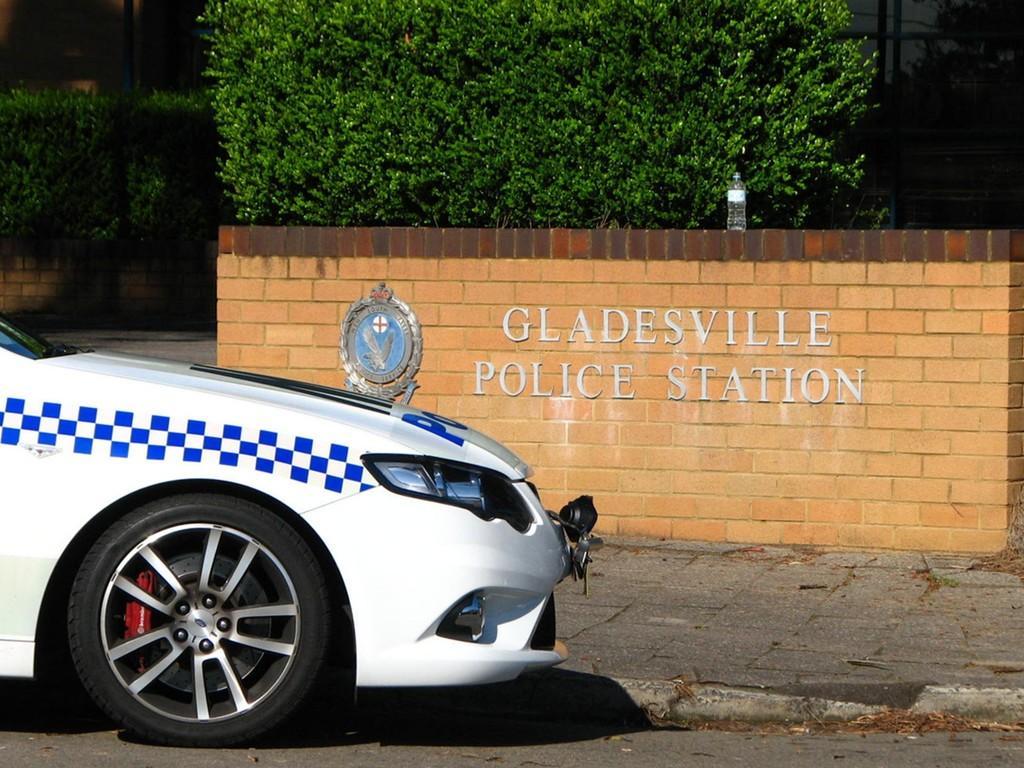How would you summarize this image in a sentence or two? At the bottom of the image we can see a car on the road. In the background there is a wall and we can see a bottle placed on the wall. We can see bushes. 